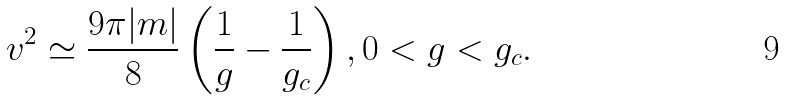Convert formula to latex. <formula><loc_0><loc_0><loc_500><loc_500>v ^ { 2 } \simeq \frac { 9 \pi | m | } { 8 } \left ( \frac { 1 } { g } - \frac { 1 } { g _ { c } } \right ) , 0 < g < g _ { c } .</formula> 